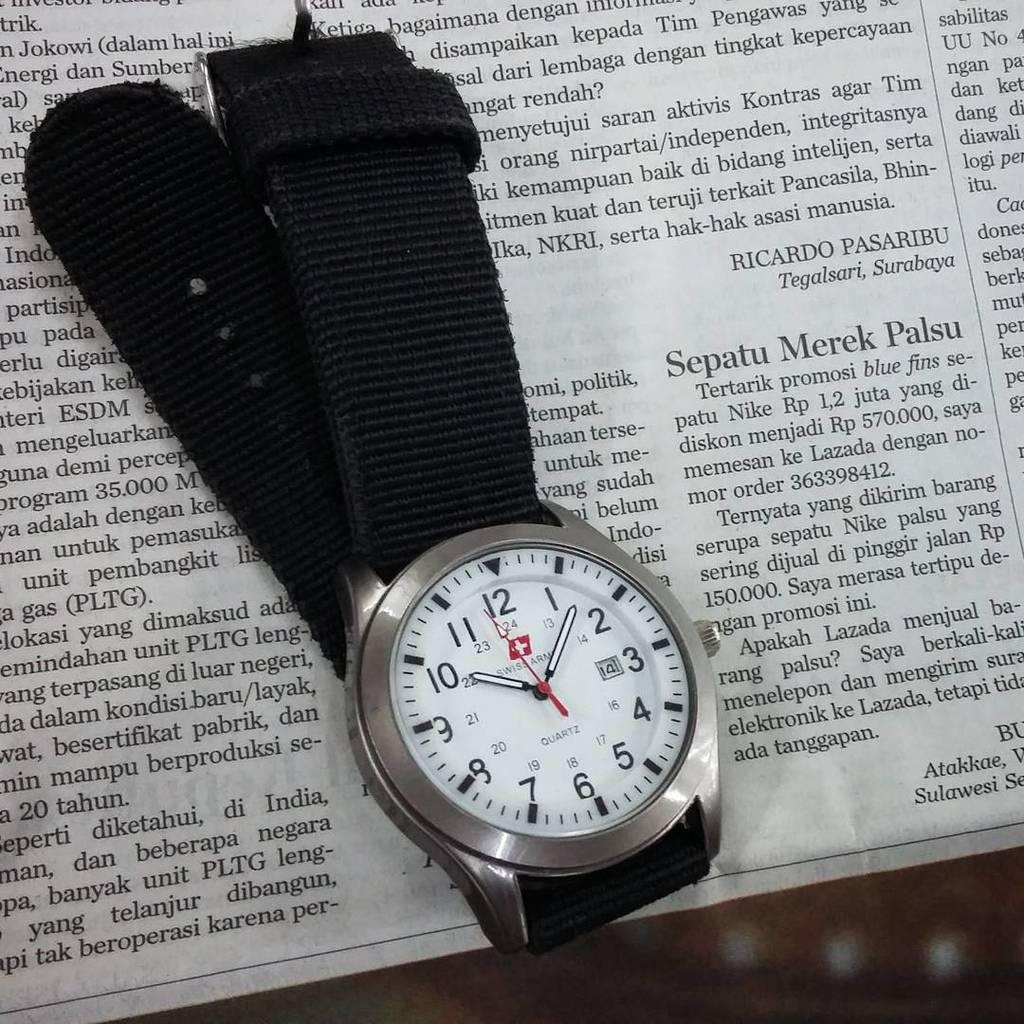<image>
Summarize the visual content of the image. A Swiss Army Quartz watch is sitting on a newspaper. 